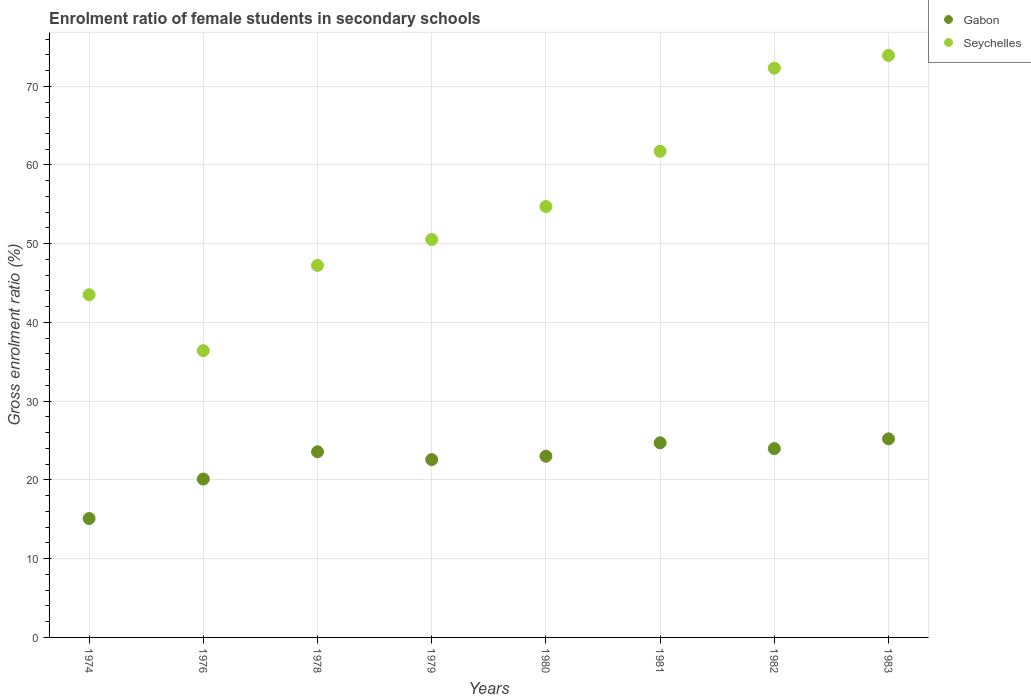How many different coloured dotlines are there?
Ensure brevity in your answer.  2. Is the number of dotlines equal to the number of legend labels?
Provide a short and direct response. Yes. What is the enrolment ratio of female students in secondary schools in Seychelles in 1979?
Offer a very short reply. 50.53. Across all years, what is the maximum enrolment ratio of female students in secondary schools in Gabon?
Offer a terse response. 25.22. Across all years, what is the minimum enrolment ratio of female students in secondary schools in Gabon?
Offer a very short reply. 15.1. In which year was the enrolment ratio of female students in secondary schools in Seychelles minimum?
Give a very brief answer. 1976. What is the total enrolment ratio of female students in secondary schools in Seychelles in the graph?
Offer a terse response. 440.41. What is the difference between the enrolment ratio of female students in secondary schools in Gabon in 1978 and that in 1981?
Give a very brief answer. -1.14. What is the difference between the enrolment ratio of female students in secondary schools in Gabon in 1976 and the enrolment ratio of female students in secondary schools in Seychelles in 1974?
Make the answer very short. -23.41. What is the average enrolment ratio of female students in secondary schools in Gabon per year?
Your response must be concise. 22.29. In the year 1982, what is the difference between the enrolment ratio of female students in secondary schools in Seychelles and enrolment ratio of female students in secondary schools in Gabon?
Offer a very short reply. 48.31. In how many years, is the enrolment ratio of female students in secondary schools in Seychelles greater than 18 %?
Your response must be concise. 8. What is the ratio of the enrolment ratio of female students in secondary schools in Gabon in 1979 to that in 1981?
Make the answer very short. 0.91. Is the enrolment ratio of female students in secondary schools in Seychelles in 1981 less than that in 1983?
Offer a terse response. Yes. Is the difference between the enrolment ratio of female students in secondary schools in Seychelles in 1976 and 1980 greater than the difference between the enrolment ratio of female students in secondary schools in Gabon in 1976 and 1980?
Offer a very short reply. No. What is the difference between the highest and the second highest enrolment ratio of female students in secondary schools in Gabon?
Give a very brief answer. 0.5. What is the difference between the highest and the lowest enrolment ratio of female students in secondary schools in Seychelles?
Provide a succinct answer. 37.49. Is the sum of the enrolment ratio of female students in secondary schools in Gabon in 1978 and 1981 greater than the maximum enrolment ratio of female students in secondary schools in Seychelles across all years?
Your response must be concise. No. How many dotlines are there?
Provide a short and direct response. 2. What is the difference between two consecutive major ticks on the Y-axis?
Your answer should be compact. 10. Are the values on the major ticks of Y-axis written in scientific E-notation?
Your response must be concise. No. Does the graph contain any zero values?
Provide a succinct answer. No. Does the graph contain grids?
Give a very brief answer. Yes. Where does the legend appear in the graph?
Your answer should be very brief. Top right. How many legend labels are there?
Provide a short and direct response. 2. How are the legend labels stacked?
Give a very brief answer. Vertical. What is the title of the graph?
Your response must be concise. Enrolment ratio of female students in secondary schools. Does "Austria" appear as one of the legend labels in the graph?
Provide a succinct answer. No. What is the label or title of the X-axis?
Your answer should be very brief. Years. What is the label or title of the Y-axis?
Your answer should be compact. Gross enrolment ratio (%). What is the Gross enrolment ratio (%) in Gabon in 1974?
Keep it short and to the point. 15.1. What is the Gross enrolment ratio (%) in Seychelles in 1974?
Offer a very short reply. 43.52. What is the Gross enrolment ratio (%) of Gabon in 1976?
Provide a short and direct response. 20.11. What is the Gross enrolment ratio (%) in Seychelles in 1976?
Offer a terse response. 36.42. What is the Gross enrolment ratio (%) in Gabon in 1978?
Your answer should be compact. 23.58. What is the Gross enrolment ratio (%) in Seychelles in 1978?
Provide a succinct answer. 47.25. What is the Gross enrolment ratio (%) of Gabon in 1979?
Provide a succinct answer. 22.59. What is the Gross enrolment ratio (%) in Seychelles in 1979?
Provide a short and direct response. 50.53. What is the Gross enrolment ratio (%) in Gabon in 1980?
Your answer should be very brief. 23.01. What is the Gross enrolment ratio (%) in Seychelles in 1980?
Make the answer very short. 54.72. What is the Gross enrolment ratio (%) in Gabon in 1981?
Offer a very short reply. 24.72. What is the Gross enrolment ratio (%) in Seychelles in 1981?
Offer a very short reply. 61.74. What is the Gross enrolment ratio (%) in Gabon in 1982?
Your answer should be very brief. 23.98. What is the Gross enrolment ratio (%) in Seychelles in 1982?
Your response must be concise. 72.3. What is the Gross enrolment ratio (%) in Gabon in 1983?
Keep it short and to the point. 25.22. What is the Gross enrolment ratio (%) of Seychelles in 1983?
Offer a very short reply. 73.92. Across all years, what is the maximum Gross enrolment ratio (%) in Gabon?
Your response must be concise. 25.22. Across all years, what is the maximum Gross enrolment ratio (%) of Seychelles?
Offer a very short reply. 73.92. Across all years, what is the minimum Gross enrolment ratio (%) in Gabon?
Give a very brief answer. 15.1. Across all years, what is the minimum Gross enrolment ratio (%) in Seychelles?
Make the answer very short. 36.42. What is the total Gross enrolment ratio (%) in Gabon in the graph?
Your response must be concise. 178.32. What is the total Gross enrolment ratio (%) in Seychelles in the graph?
Offer a very short reply. 440.41. What is the difference between the Gross enrolment ratio (%) in Gabon in 1974 and that in 1976?
Ensure brevity in your answer.  -5.01. What is the difference between the Gross enrolment ratio (%) of Seychelles in 1974 and that in 1976?
Give a very brief answer. 7.1. What is the difference between the Gross enrolment ratio (%) of Gabon in 1974 and that in 1978?
Your response must be concise. -8.48. What is the difference between the Gross enrolment ratio (%) of Seychelles in 1974 and that in 1978?
Your answer should be very brief. -3.73. What is the difference between the Gross enrolment ratio (%) of Gabon in 1974 and that in 1979?
Offer a terse response. -7.49. What is the difference between the Gross enrolment ratio (%) of Seychelles in 1974 and that in 1979?
Keep it short and to the point. -7.01. What is the difference between the Gross enrolment ratio (%) in Gabon in 1974 and that in 1980?
Offer a terse response. -7.91. What is the difference between the Gross enrolment ratio (%) in Seychelles in 1974 and that in 1980?
Offer a very short reply. -11.21. What is the difference between the Gross enrolment ratio (%) in Gabon in 1974 and that in 1981?
Ensure brevity in your answer.  -9.62. What is the difference between the Gross enrolment ratio (%) in Seychelles in 1974 and that in 1981?
Offer a terse response. -18.23. What is the difference between the Gross enrolment ratio (%) of Gabon in 1974 and that in 1982?
Your answer should be compact. -8.89. What is the difference between the Gross enrolment ratio (%) in Seychelles in 1974 and that in 1982?
Offer a very short reply. -28.78. What is the difference between the Gross enrolment ratio (%) of Gabon in 1974 and that in 1983?
Give a very brief answer. -10.12. What is the difference between the Gross enrolment ratio (%) in Seychelles in 1974 and that in 1983?
Offer a very short reply. -30.4. What is the difference between the Gross enrolment ratio (%) in Gabon in 1976 and that in 1978?
Offer a very short reply. -3.47. What is the difference between the Gross enrolment ratio (%) in Seychelles in 1976 and that in 1978?
Offer a very short reply. -10.82. What is the difference between the Gross enrolment ratio (%) in Gabon in 1976 and that in 1979?
Give a very brief answer. -2.48. What is the difference between the Gross enrolment ratio (%) in Seychelles in 1976 and that in 1979?
Provide a succinct answer. -14.11. What is the difference between the Gross enrolment ratio (%) in Gabon in 1976 and that in 1980?
Provide a short and direct response. -2.9. What is the difference between the Gross enrolment ratio (%) of Seychelles in 1976 and that in 1980?
Provide a succinct answer. -18.3. What is the difference between the Gross enrolment ratio (%) of Gabon in 1976 and that in 1981?
Provide a succinct answer. -4.61. What is the difference between the Gross enrolment ratio (%) in Seychelles in 1976 and that in 1981?
Offer a terse response. -25.32. What is the difference between the Gross enrolment ratio (%) of Gabon in 1976 and that in 1982?
Your answer should be very brief. -3.87. What is the difference between the Gross enrolment ratio (%) of Seychelles in 1976 and that in 1982?
Provide a succinct answer. -35.87. What is the difference between the Gross enrolment ratio (%) of Gabon in 1976 and that in 1983?
Offer a very short reply. -5.11. What is the difference between the Gross enrolment ratio (%) in Seychelles in 1976 and that in 1983?
Your answer should be very brief. -37.49. What is the difference between the Gross enrolment ratio (%) of Gabon in 1978 and that in 1979?
Offer a terse response. 0.99. What is the difference between the Gross enrolment ratio (%) of Seychelles in 1978 and that in 1979?
Your answer should be very brief. -3.29. What is the difference between the Gross enrolment ratio (%) of Gabon in 1978 and that in 1980?
Your answer should be compact. 0.57. What is the difference between the Gross enrolment ratio (%) of Seychelles in 1978 and that in 1980?
Provide a succinct answer. -7.48. What is the difference between the Gross enrolment ratio (%) in Gabon in 1978 and that in 1981?
Your answer should be compact. -1.14. What is the difference between the Gross enrolment ratio (%) in Seychelles in 1978 and that in 1981?
Keep it short and to the point. -14.5. What is the difference between the Gross enrolment ratio (%) of Gabon in 1978 and that in 1982?
Offer a very short reply. -0.4. What is the difference between the Gross enrolment ratio (%) in Seychelles in 1978 and that in 1982?
Offer a terse response. -25.05. What is the difference between the Gross enrolment ratio (%) of Gabon in 1978 and that in 1983?
Provide a succinct answer. -1.64. What is the difference between the Gross enrolment ratio (%) of Seychelles in 1978 and that in 1983?
Your answer should be very brief. -26.67. What is the difference between the Gross enrolment ratio (%) in Gabon in 1979 and that in 1980?
Keep it short and to the point. -0.42. What is the difference between the Gross enrolment ratio (%) in Seychelles in 1979 and that in 1980?
Your answer should be compact. -4.19. What is the difference between the Gross enrolment ratio (%) in Gabon in 1979 and that in 1981?
Provide a short and direct response. -2.13. What is the difference between the Gross enrolment ratio (%) of Seychelles in 1979 and that in 1981?
Keep it short and to the point. -11.21. What is the difference between the Gross enrolment ratio (%) in Gabon in 1979 and that in 1982?
Give a very brief answer. -1.4. What is the difference between the Gross enrolment ratio (%) of Seychelles in 1979 and that in 1982?
Provide a short and direct response. -21.76. What is the difference between the Gross enrolment ratio (%) in Gabon in 1979 and that in 1983?
Offer a very short reply. -2.63. What is the difference between the Gross enrolment ratio (%) of Seychelles in 1979 and that in 1983?
Your response must be concise. -23.38. What is the difference between the Gross enrolment ratio (%) of Gabon in 1980 and that in 1981?
Offer a terse response. -1.71. What is the difference between the Gross enrolment ratio (%) of Seychelles in 1980 and that in 1981?
Provide a short and direct response. -7.02. What is the difference between the Gross enrolment ratio (%) of Gabon in 1980 and that in 1982?
Offer a terse response. -0.97. What is the difference between the Gross enrolment ratio (%) of Seychelles in 1980 and that in 1982?
Ensure brevity in your answer.  -17.57. What is the difference between the Gross enrolment ratio (%) of Gabon in 1980 and that in 1983?
Your answer should be compact. -2.21. What is the difference between the Gross enrolment ratio (%) of Seychelles in 1980 and that in 1983?
Ensure brevity in your answer.  -19.19. What is the difference between the Gross enrolment ratio (%) of Gabon in 1981 and that in 1982?
Your response must be concise. 0.74. What is the difference between the Gross enrolment ratio (%) in Seychelles in 1981 and that in 1982?
Offer a very short reply. -10.55. What is the difference between the Gross enrolment ratio (%) of Gabon in 1981 and that in 1983?
Keep it short and to the point. -0.5. What is the difference between the Gross enrolment ratio (%) in Seychelles in 1981 and that in 1983?
Provide a succinct answer. -12.17. What is the difference between the Gross enrolment ratio (%) of Gabon in 1982 and that in 1983?
Ensure brevity in your answer.  -1.24. What is the difference between the Gross enrolment ratio (%) in Seychelles in 1982 and that in 1983?
Ensure brevity in your answer.  -1.62. What is the difference between the Gross enrolment ratio (%) in Gabon in 1974 and the Gross enrolment ratio (%) in Seychelles in 1976?
Offer a very short reply. -21.33. What is the difference between the Gross enrolment ratio (%) in Gabon in 1974 and the Gross enrolment ratio (%) in Seychelles in 1978?
Provide a succinct answer. -32.15. What is the difference between the Gross enrolment ratio (%) in Gabon in 1974 and the Gross enrolment ratio (%) in Seychelles in 1979?
Provide a succinct answer. -35.44. What is the difference between the Gross enrolment ratio (%) in Gabon in 1974 and the Gross enrolment ratio (%) in Seychelles in 1980?
Provide a short and direct response. -39.63. What is the difference between the Gross enrolment ratio (%) of Gabon in 1974 and the Gross enrolment ratio (%) of Seychelles in 1981?
Provide a succinct answer. -46.65. What is the difference between the Gross enrolment ratio (%) in Gabon in 1974 and the Gross enrolment ratio (%) in Seychelles in 1982?
Ensure brevity in your answer.  -57.2. What is the difference between the Gross enrolment ratio (%) of Gabon in 1974 and the Gross enrolment ratio (%) of Seychelles in 1983?
Your answer should be compact. -58.82. What is the difference between the Gross enrolment ratio (%) of Gabon in 1976 and the Gross enrolment ratio (%) of Seychelles in 1978?
Provide a short and direct response. -27.13. What is the difference between the Gross enrolment ratio (%) in Gabon in 1976 and the Gross enrolment ratio (%) in Seychelles in 1979?
Ensure brevity in your answer.  -30.42. What is the difference between the Gross enrolment ratio (%) in Gabon in 1976 and the Gross enrolment ratio (%) in Seychelles in 1980?
Keep it short and to the point. -34.61. What is the difference between the Gross enrolment ratio (%) of Gabon in 1976 and the Gross enrolment ratio (%) of Seychelles in 1981?
Your answer should be compact. -41.63. What is the difference between the Gross enrolment ratio (%) in Gabon in 1976 and the Gross enrolment ratio (%) in Seychelles in 1982?
Make the answer very short. -52.18. What is the difference between the Gross enrolment ratio (%) of Gabon in 1976 and the Gross enrolment ratio (%) of Seychelles in 1983?
Offer a very short reply. -53.81. What is the difference between the Gross enrolment ratio (%) in Gabon in 1978 and the Gross enrolment ratio (%) in Seychelles in 1979?
Keep it short and to the point. -26.95. What is the difference between the Gross enrolment ratio (%) in Gabon in 1978 and the Gross enrolment ratio (%) in Seychelles in 1980?
Offer a very short reply. -31.15. What is the difference between the Gross enrolment ratio (%) of Gabon in 1978 and the Gross enrolment ratio (%) of Seychelles in 1981?
Provide a short and direct response. -38.17. What is the difference between the Gross enrolment ratio (%) in Gabon in 1978 and the Gross enrolment ratio (%) in Seychelles in 1982?
Give a very brief answer. -48.72. What is the difference between the Gross enrolment ratio (%) in Gabon in 1978 and the Gross enrolment ratio (%) in Seychelles in 1983?
Your answer should be compact. -50.34. What is the difference between the Gross enrolment ratio (%) in Gabon in 1979 and the Gross enrolment ratio (%) in Seychelles in 1980?
Make the answer very short. -32.14. What is the difference between the Gross enrolment ratio (%) of Gabon in 1979 and the Gross enrolment ratio (%) of Seychelles in 1981?
Your answer should be compact. -39.16. What is the difference between the Gross enrolment ratio (%) of Gabon in 1979 and the Gross enrolment ratio (%) of Seychelles in 1982?
Offer a terse response. -49.71. What is the difference between the Gross enrolment ratio (%) of Gabon in 1979 and the Gross enrolment ratio (%) of Seychelles in 1983?
Make the answer very short. -51.33. What is the difference between the Gross enrolment ratio (%) of Gabon in 1980 and the Gross enrolment ratio (%) of Seychelles in 1981?
Your response must be concise. -38.73. What is the difference between the Gross enrolment ratio (%) in Gabon in 1980 and the Gross enrolment ratio (%) in Seychelles in 1982?
Make the answer very short. -49.28. What is the difference between the Gross enrolment ratio (%) in Gabon in 1980 and the Gross enrolment ratio (%) in Seychelles in 1983?
Your answer should be compact. -50.91. What is the difference between the Gross enrolment ratio (%) in Gabon in 1981 and the Gross enrolment ratio (%) in Seychelles in 1982?
Ensure brevity in your answer.  -47.58. What is the difference between the Gross enrolment ratio (%) in Gabon in 1981 and the Gross enrolment ratio (%) in Seychelles in 1983?
Provide a short and direct response. -49.2. What is the difference between the Gross enrolment ratio (%) of Gabon in 1982 and the Gross enrolment ratio (%) of Seychelles in 1983?
Provide a succinct answer. -49.93. What is the average Gross enrolment ratio (%) in Gabon per year?
Provide a short and direct response. 22.29. What is the average Gross enrolment ratio (%) in Seychelles per year?
Offer a very short reply. 55.05. In the year 1974, what is the difference between the Gross enrolment ratio (%) in Gabon and Gross enrolment ratio (%) in Seychelles?
Your response must be concise. -28.42. In the year 1976, what is the difference between the Gross enrolment ratio (%) of Gabon and Gross enrolment ratio (%) of Seychelles?
Your response must be concise. -16.31. In the year 1978, what is the difference between the Gross enrolment ratio (%) in Gabon and Gross enrolment ratio (%) in Seychelles?
Offer a very short reply. -23.67. In the year 1979, what is the difference between the Gross enrolment ratio (%) of Gabon and Gross enrolment ratio (%) of Seychelles?
Provide a short and direct response. -27.95. In the year 1980, what is the difference between the Gross enrolment ratio (%) in Gabon and Gross enrolment ratio (%) in Seychelles?
Keep it short and to the point. -31.71. In the year 1981, what is the difference between the Gross enrolment ratio (%) in Gabon and Gross enrolment ratio (%) in Seychelles?
Ensure brevity in your answer.  -37.02. In the year 1982, what is the difference between the Gross enrolment ratio (%) in Gabon and Gross enrolment ratio (%) in Seychelles?
Offer a very short reply. -48.31. In the year 1983, what is the difference between the Gross enrolment ratio (%) in Gabon and Gross enrolment ratio (%) in Seychelles?
Your answer should be very brief. -48.7. What is the ratio of the Gross enrolment ratio (%) in Gabon in 1974 to that in 1976?
Ensure brevity in your answer.  0.75. What is the ratio of the Gross enrolment ratio (%) in Seychelles in 1974 to that in 1976?
Provide a succinct answer. 1.19. What is the ratio of the Gross enrolment ratio (%) in Gabon in 1974 to that in 1978?
Offer a terse response. 0.64. What is the ratio of the Gross enrolment ratio (%) of Seychelles in 1974 to that in 1978?
Make the answer very short. 0.92. What is the ratio of the Gross enrolment ratio (%) of Gabon in 1974 to that in 1979?
Your answer should be compact. 0.67. What is the ratio of the Gross enrolment ratio (%) of Seychelles in 1974 to that in 1979?
Keep it short and to the point. 0.86. What is the ratio of the Gross enrolment ratio (%) in Gabon in 1974 to that in 1980?
Your answer should be very brief. 0.66. What is the ratio of the Gross enrolment ratio (%) of Seychelles in 1974 to that in 1980?
Provide a succinct answer. 0.8. What is the ratio of the Gross enrolment ratio (%) of Gabon in 1974 to that in 1981?
Provide a succinct answer. 0.61. What is the ratio of the Gross enrolment ratio (%) in Seychelles in 1974 to that in 1981?
Your answer should be compact. 0.7. What is the ratio of the Gross enrolment ratio (%) of Gabon in 1974 to that in 1982?
Your answer should be compact. 0.63. What is the ratio of the Gross enrolment ratio (%) in Seychelles in 1974 to that in 1982?
Your answer should be very brief. 0.6. What is the ratio of the Gross enrolment ratio (%) of Gabon in 1974 to that in 1983?
Make the answer very short. 0.6. What is the ratio of the Gross enrolment ratio (%) of Seychelles in 1974 to that in 1983?
Make the answer very short. 0.59. What is the ratio of the Gross enrolment ratio (%) in Gabon in 1976 to that in 1978?
Ensure brevity in your answer.  0.85. What is the ratio of the Gross enrolment ratio (%) in Seychelles in 1976 to that in 1978?
Provide a succinct answer. 0.77. What is the ratio of the Gross enrolment ratio (%) of Gabon in 1976 to that in 1979?
Provide a short and direct response. 0.89. What is the ratio of the Gross enrolment ratio (%) of Seychelles in 1976 to that in 1979?
Ensure brevity in your answer.  0.72. What is the ratio of the Gross enrolment ratio (%) in Gabon in 1976 to that in 1980?
Give a very brief answer. 0.87. What is the ratio of the Gross enrolment ratio (%) of Seychelles in 1976 to that in 1980?
Give a very brief answer. 0.67. What is the ratio of the Gross enrolment ratio (%) of Gabon in 1976 to that in 1981?
Make the answer very short. 0.81. What is the ratio of the Gross enrolment ratio (%) in Seychelles in 1976 to that in 1981?
Provide a succinct answer. 0.59. What is the ratio of the Gross enrolment ratio (%) of Gabon in 1976 to that in 1982?
Give a very brief answer. 0.84. What is the ratio of the Gross enrolment ratio (%) of Seychelles in 1976 to that in 1982?
Provide a short and direct response. 0.5. What is the ratio of the Gross enrolment ratio (%) in Gabon in 1976 to that in 1983?
Provide a succinct answer. 0.8. What is the ratio of the Gross enrolment ratio (%) of Seychelles in 1976 to that in 1983?
Your response must be concise. 0.49. What is the ratio of the Gross enrolment ratio (%) of Gabon in 1978 to that in 1979?
Keep it short and to the point. 1.04. What is the ratio of the Gross enrolment ratio (%) of Seychelles in 1978 to that in 1979?
Make the answer very short. 0.94. What is the ratio of the Gross enrolment ratio (%) in Gabon in 1978 to that in 1980?
Ensure brevity in your answer.  1.02. What is the ratio of the Gross enrolment ratio (%) of Seychelles in 1978 to that in 1980?
Offer a very short reply. 0.86. What is the ratio of the Gross enrolment ratio (%) of Gabon in 1978 to that in 1981?
Provide a succinct answer. 0.95. What is the ratio of the Gross enrolment ratio (%) of Seychelles in 1978 to that in 1981?
Give a very brief answer. 0.77. What is the ratio of the Gross enrolment ratio (%) of Gabon in 1978 to that in 1982?
Give a very brief answer. 0.98. What is the ratio of the Gross enrolment ratio (%) of Seychelles in 1978 to that in 1982?
Provide a succinct answer. 0.65. What is the ratio of the Gross enrolment ratio (%) of Gabon in 1978 to that in 1983?
Make the answer very short. 0.93. What is the ratio of the Gross enrolment ratio (%) of Seychelles in 1978 to that in 1983?
Offer a terse response. 0.64. What is the ratio of the Gross enrolment ratio (%) of Gabon in 1979 to that in 1980?
Your answer should be compact. 0.98. What is the ratio of the Gross enrolment ratio (%) in Seychelles in 1979 to that in 1980?
Offer a terse response. 0.92. What is the ratio of the Gross enrolment ratio (%) in Gabon in 1979 to that in 1981?
Offer a terse response. 0.91. What is the ratio of the Gross enrolment ratio (%) of Seychelles in 1979 to that in 1981?
Provide a short and direct response. 0.82. What is the ratio of the Gross enrolment ratio (%) in Gabon in 1979 to that in 1982?
Offer a terse response. 0.94. What is the ratio of the Gross enrolment ratio (%) in Seychelles in 1979 to that in 1982?
Your answer should be very brief. 0.7. What is the ratio of the Gross enrolment ratio (%) of Gabon in 1979 to that in 1983?
Keep it short and to the point. 0.9. What is the ratio of the Gross enrolment ratio (%) of Seychelles in 1979 to that in 1983?
Provide a succinct answer. 0.68. What is the ratio of the Gross enrolment ratio (%) of Gabon in 1980 to that in 1981?
Offer a terse response. 0.93. What is the ratio of the Gross enrolment ratio (%) of Seychelles in 1980 to that in 1981?
Ensure brevity in your answer.  0.89. What is the ratio of the Gross enrolment ratio (%) in Gabon in 1980 to that in 1982?
Make the answer very short. 0.96. What is the ratio of the Gross enrolment ratio (%) in Seychelles in 1980 to that in 1982?
Your response must be concise. 0.76. What is the ratio of the Gross enrolment ratio (%) of Gabon in 1980 to that in 1983?
Keep it short and to the point. 0.91. What is the ratio of the Gross enrolment ratio (%) in Seychelles in 1980 to that in 1983?
Your response must be concise. 0.74. What is the ratio of the Gross enrolment ratio (%) of Gabon in 1981 to that in 1982?
Your answer should be compact. 1.03. What is the ratio of the Gross enrolment ratio (%) in Seychelles in 1981 to that in 1982?
Offer a very short reply. 0.85. What is the ratio of the Gross enrolment ratio (%) in Gabon in 1981 to that in 1983?
Make the answer very short. 0.98. What is the ratio of the Gross enrolment ratio (%) in Seychelles in 1981 to that in 1983?
Give a very brief answer. 0.84. What is the ratio of the Gross enrolment ratio (%) in Gabon in 1982 to that in 1983?
Keep it short and to the point. 0.95. What is the ratio of the Gross enrolment ratio (%) of Seychelles in 1982 to that in 1983?
Your response must be concise. 0.98. What is the difference between the highest and the second highest Gross enrolment ratio (%) in Gabon?
Make the answer very short. 0.5. What is the difference between the highest and the second highest Gross enrolment ratio (%) in Seychelles?
Give a very brief answer. 1.62. What is the difference between the highest and the lowest Gross enrolment ratio (%) in Gabon?
Your answer should be compact. 10.12. What is the difference between the highest and the lowest Gross enrolment ratio (%) of Seychelles?
Provide a short and direct response. 37.49. 